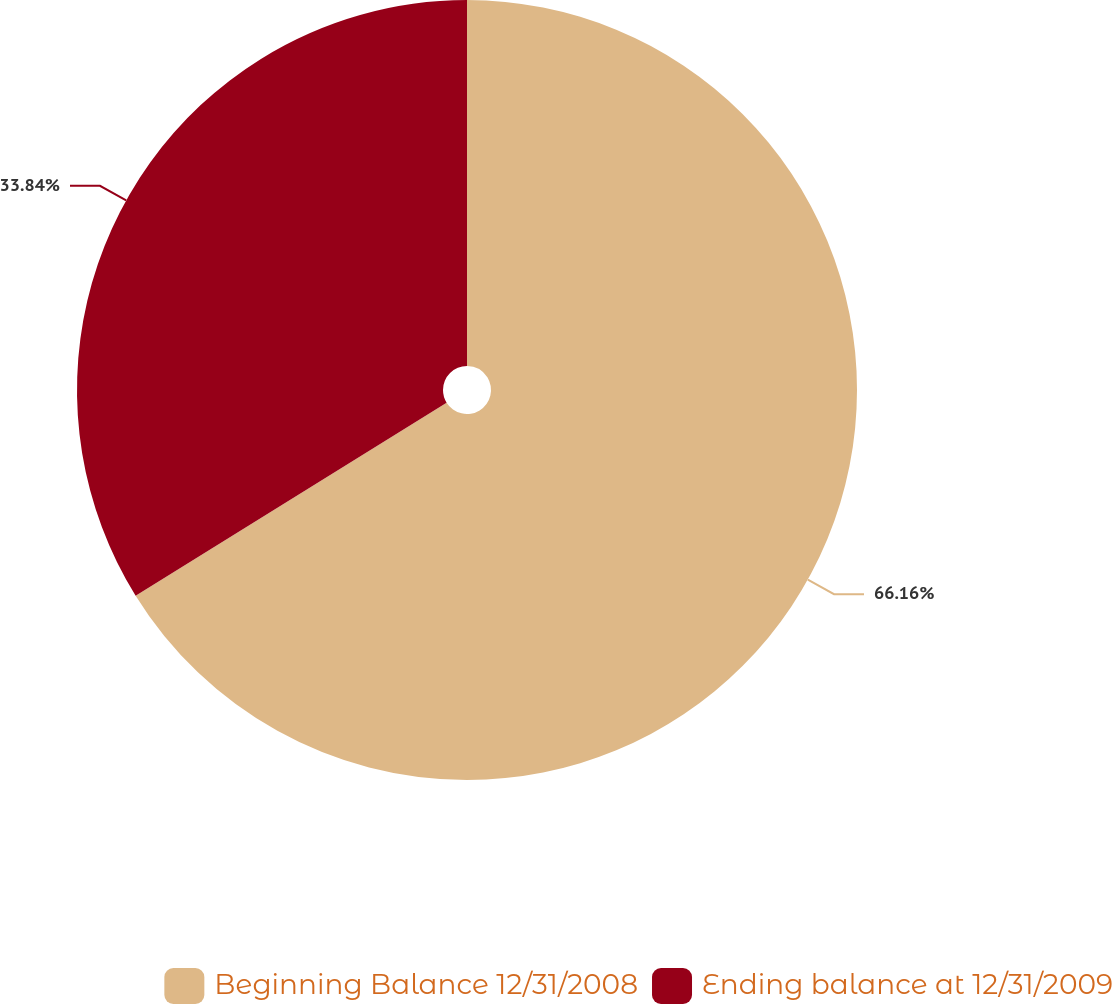Convert chart. <chart><loc_0><loc_0><loc_500><loc_500><pie_chart><fcel>Beginning Balance 12/31/2008<fcel>Ending balance at 12/31/2009<nl><fcel>66.16%<fcel>33.84%<nl></chart> 